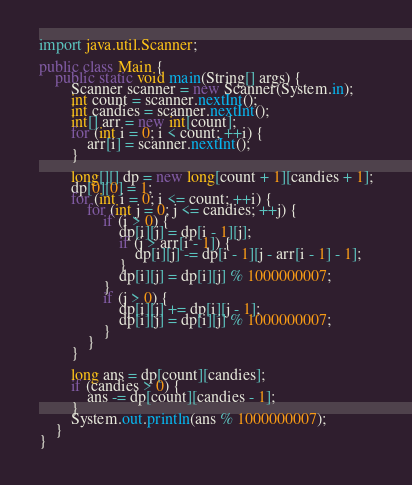Convert code to text. <code><loc_0><loc_0><loc_500><loc_500><_Java_>import java.util.Scanner;

public class Main {
    public static void main(String[] args) {
        Scanner scanner = new Scanner(System.in);
        int count = scanner.nextInt();
        int candies = scanner.nextInt();
        int[] arr = new int[count];
        for (int i = 0; i < count; ++i) {
            arr[i] = scanner.nextInt();
        }

        long[][] dp = new long[count + 1][candies + 1];
        dp[0][0] = 1;
        for (int i = 0; i <= count; ++i) {
            for (int j = 0; j <= candies; ++j) {
                if (i > 0) {
                    dp[i][j] = dp[i - 1][j];
                    if (j > arr[i - 1]) {
                        dp[i][j] -= dp[i - 1][j - arr[i - 1] - 1];
                    }
                    dp[i][j] = dp[i][j] % 1000000007;
                }
                if (j > 0) {
                    dp[i][j] += dp[i][j - 1];
                    dp[i][j] = dp[i][j] % 1000000007;
                }
            }
        }

        long ans = dp[count][candies];
        if (candies > 0) {
            ans -= dp[count][candies - 1];
        }
        System.out.println(ans % 1000000007);
    }
}
</code> 